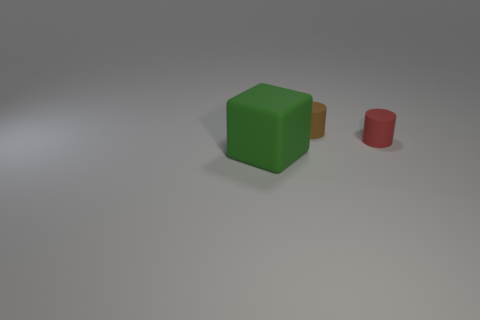Add 3 brown things. How many objects exist? 6 Subtract all cylinders. How many objects are left? 1 Subtract all large gray matte spheres. Subtract all big rubber cubes. How many objects are left? 2 Add 3 small red things. How many small red things are left? 4 Add 1 matte cylinders. How many matte cylinders exist? 3 Subtract 0 purple cylinders. How many objects are left? 3 